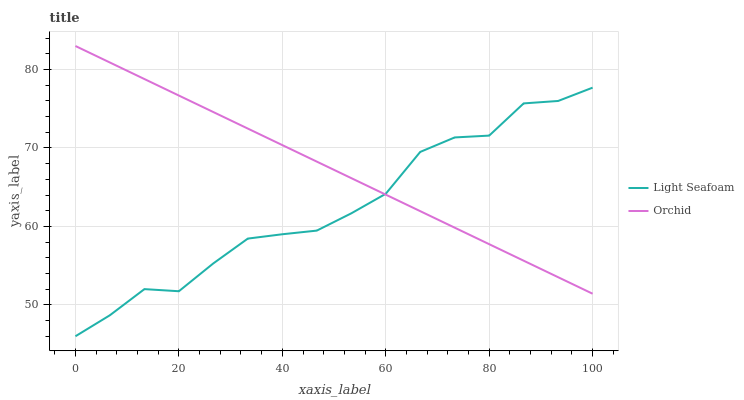Does Light Seafoam have the minimum area under the curve?
Answer yes or no. Yes. Does Orchid have the maximum area under the curve?
Answer yes or no. Yes. Does Orchid have the minimum area under the curve?
Answer yes or no. No. Is Orchid the smoothest?
Answer yes or no. Yes. Is Light Seafoam the roughest?
Answer yes or no. Yes. Is Orchid the roughest?
Answer yes or no. No. Does Light Seafoam have the lowest value?
Answer yes or no. Yes. Does Orchid have the lowest value?
Answer yes or no. No. Does Orchid have the highest value?
Answer yes or no. Yes. Does Light Seafoam intersect Orchid?
Answer yes or no. Yes. Is Light Seafoam less than Orchid?
Answer yes or no. No. Is Light Seafoam greater than Orchid?
Answer yes or no. No. 